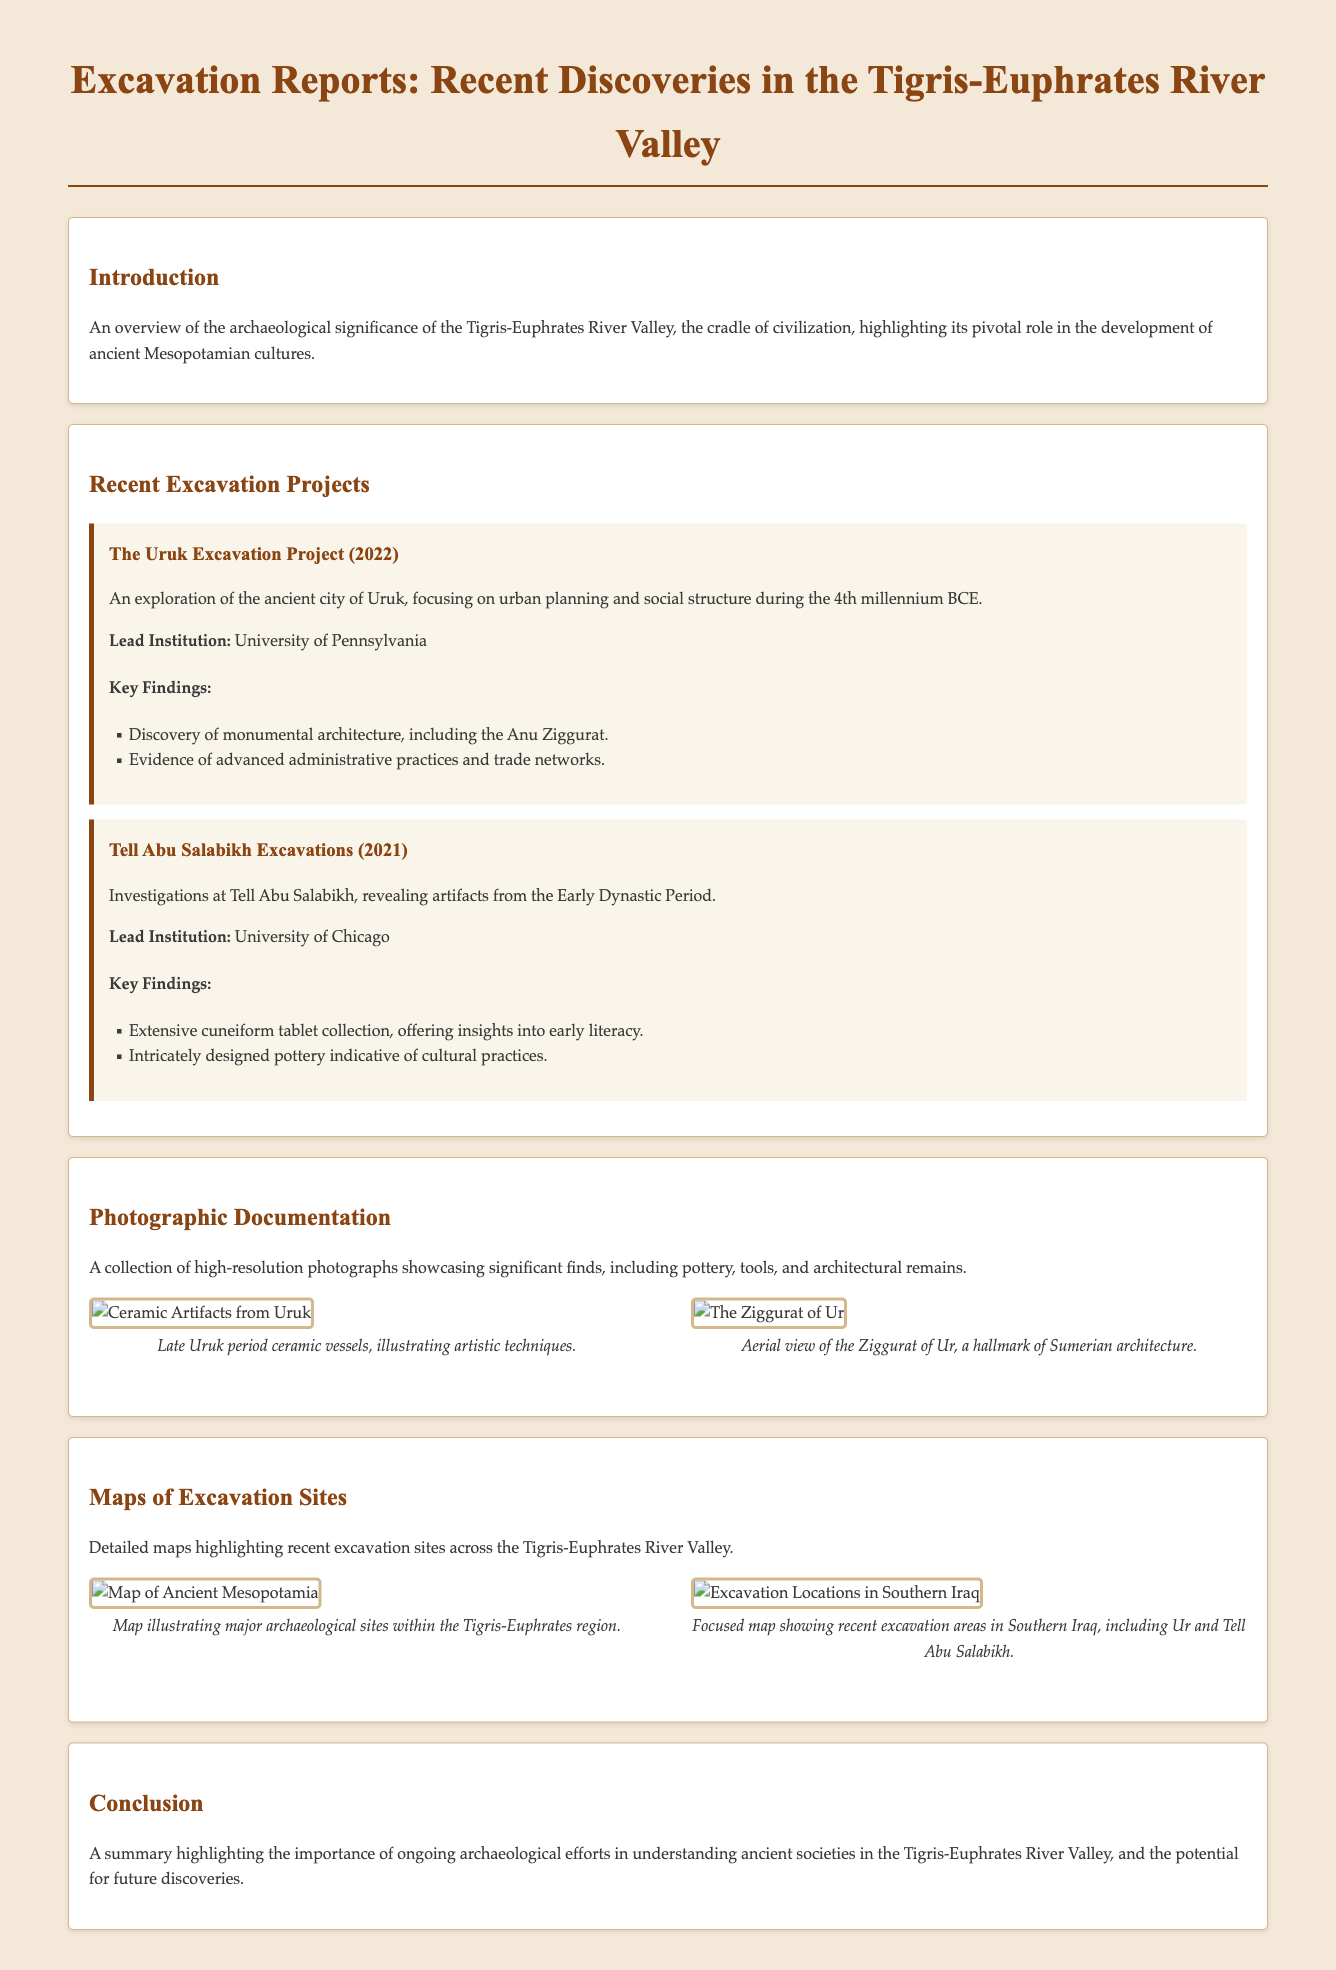What is the title of the document? The title is presented in the header of the document, which is "Excavation Reports: Recent Discoveries in the Tigris-Euphrates River Valley."
Answer: Excavation Reports: Recent Discoveries in the Tigris-Euphrates River Valley Who is the lead institution for the Uruk Excavation Project? The document specifies that the lead institution for the Uruk Excavation Project is the University of Pennsylvania.
Answer: University of Pennsylvania In what year was the Tell Abu Salabikh Excavation conducted? The document states that the Tell Abu Salabikh Excavation took place in 2021.
Answer: 2021 What type of artifacts were found in Tell Abu Salabikh? The document indicates that there was an extensive collection of cuneiform tablets found, among other artifacts.
Answer: Cuneiform tablets What architectural structure is highlighted in the Uruk Excavation Project? The report mentions the discovery of monumental architecture, specifically the Anu Ziggurat, during the Uruk Excavation Project.
Answer: Anu Ziggurat How many significant excavation projects are listed in the document? The document lists a total of two significant excavation projects under the Recent Excavation Projects section.
Answer: Two What type of photographic documentation is included in the report? The section discusses high-resolution photographs showcasing significant finds including pottery, tools, and architectural remains.
Answer: Significant finds including pottery, tools, and architectural remains What does the section on maps highlight? The Maps of Excavation Sites section emphasizes detailed maps highlighting recent excavation sites across the Tigris-Euphrates River Valley.
Answer: Recent excavation sites across the Tigris-Euphrates River Valley What is described in the introduction of the document? The introduction provides an overview of the archaeological significance of the Tigris-Euphrates River Valley and its role in ancient Mesopotamian cultures.
Answer: Overview of the archaeological significance of the Tigris-Euphrates River Valley 